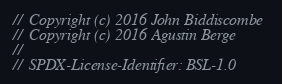<code> <loc_0><loc_0><loc_500><loc_500><_C++_>//  Copyright (c) 2016 John Biddiscombe
//  Copyright (c) 2016 Agustin Berge
//
//  SPDX-License-Identifier: BSL-1.0</code> 